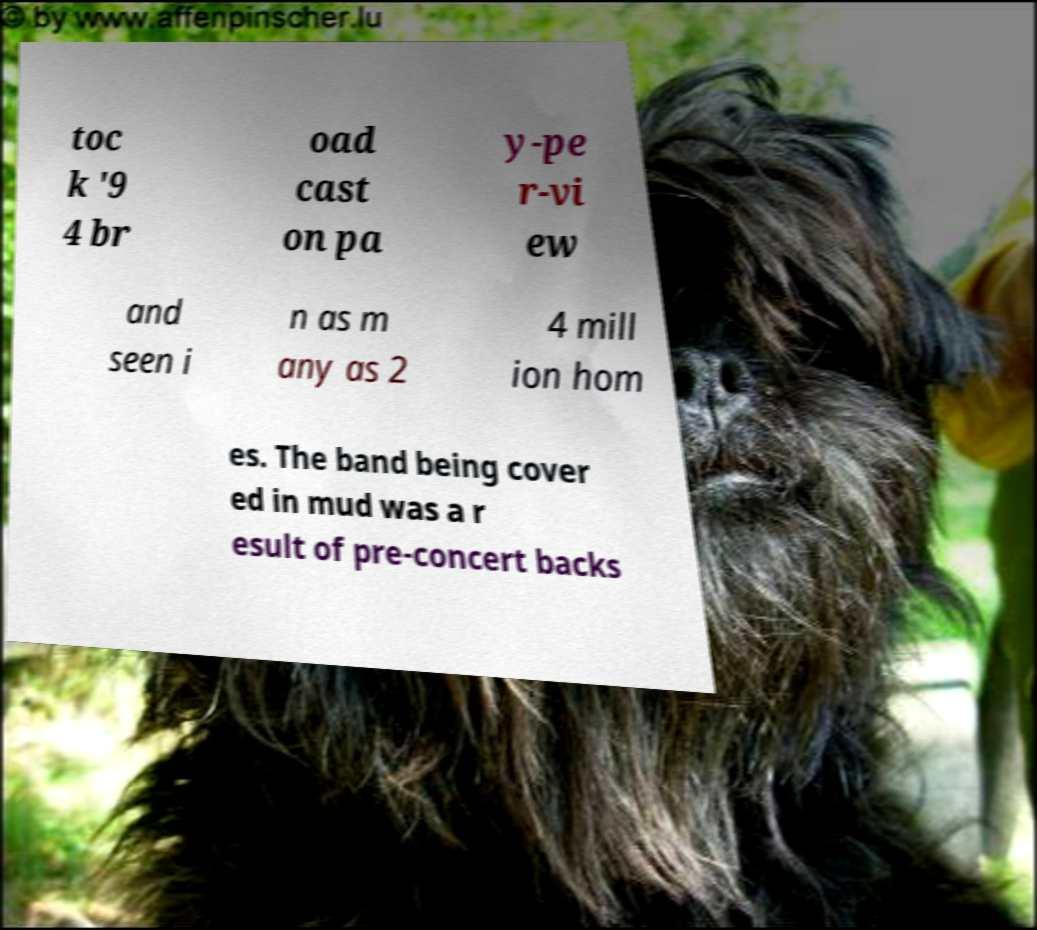What messages or text are displayed in this image? I need them in a readable, typed format. toc k '9 4 br oad cast on pa y-pe r-vi ew and seen i n as m any as 2 4 mill ion hom es. The band being cover ed in mud was a r esult of pre-concert backs 